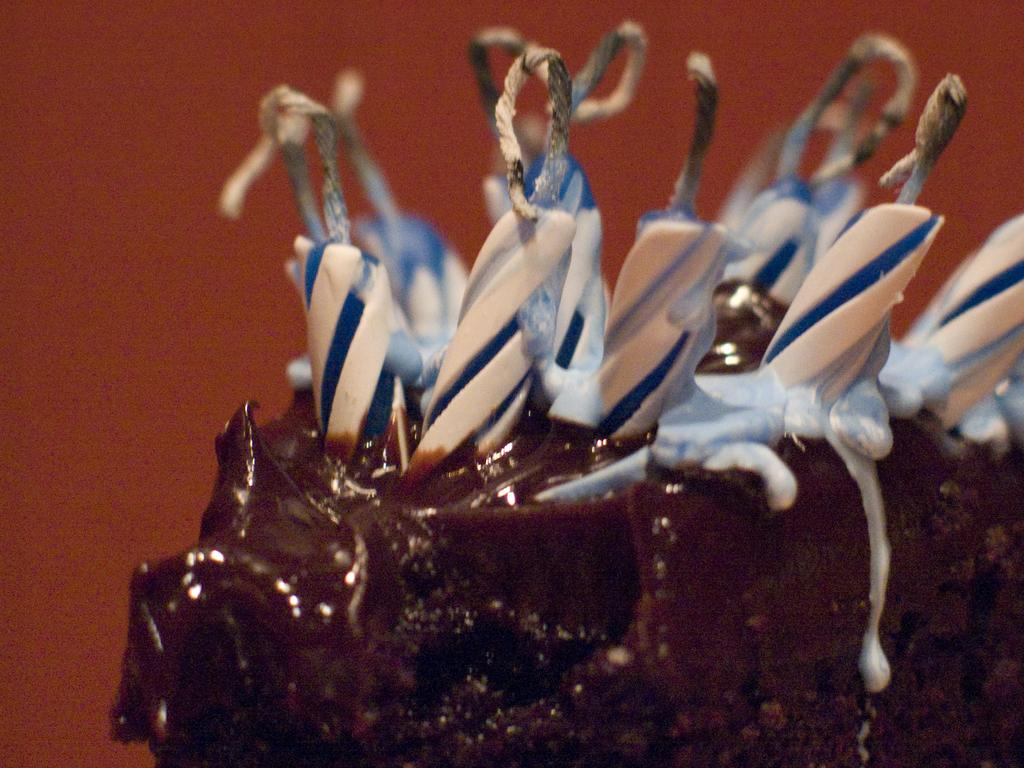What is the main subject of the image? There is a cake in the center of the image. What is placed on top of the cake? There are candles on the cake. What can be seen in the background of the image? There is a wall visible in the background of the image. How many cakes are being prepared by the team in the image? There is no team or additional cakes present in the image; it only features a single cake with candles. What type of rings can be seen on the fingers of the people in the image? There are no people or rings visible in the image; it only features a cake with candles and a wall in the background. 